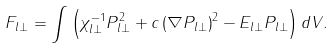<formula> <loc_0><loc_0><loc_500><loc_500>F _ { l \bot } = \int { \left ( { \chi _ { l \bot } ^ { - 1 } P _ { l \bot } ^ { 2 } + c \left ( { \nabla P _ { l \bot } } \right ) ^ { 2 } - E _ { l \bot } P _ { l \bot } } \right ) d V } .</formula> 